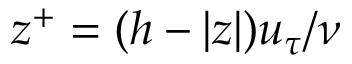<formula> <loc_0><loc_0><loc_500><loc_500>z ^ { + } = ( h - | z | ) u _ { \tau } / \nu</formula> 